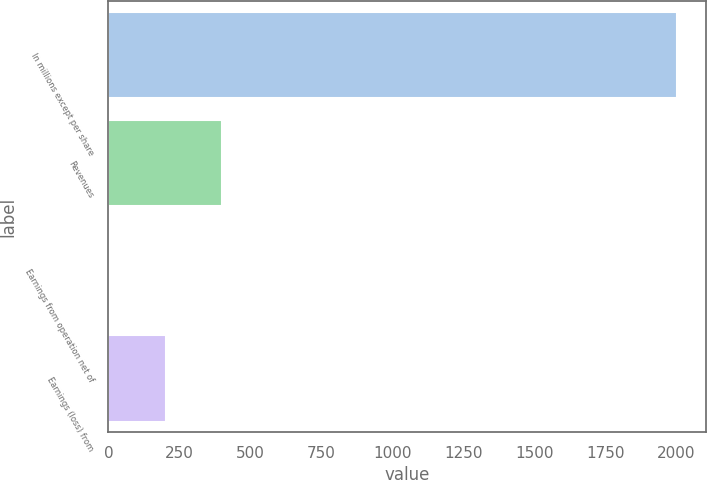<chart> <loc_0><loc_0><loc_500><loc_500><bar_chart><fcel>In millions except per share<fcel>Revenues<fcel>Earnings from operation net of<fcel>Earnings (loss) from<nl><fcel>2004<fcel>401.6<fcel>1<fcel>201.3<nl></chart> 